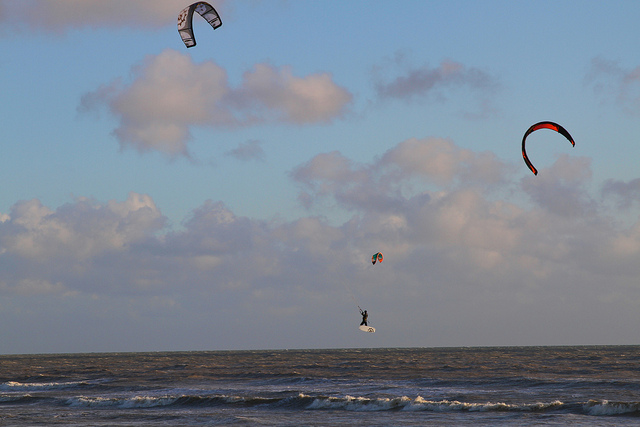Where is the kite surfer located in relation to the kites? The kite surfer is masterfully positioned beneath the majestic canopy of kites, centered between two of these soaring emblems, seemingly in a harmonious dance with the elements. 